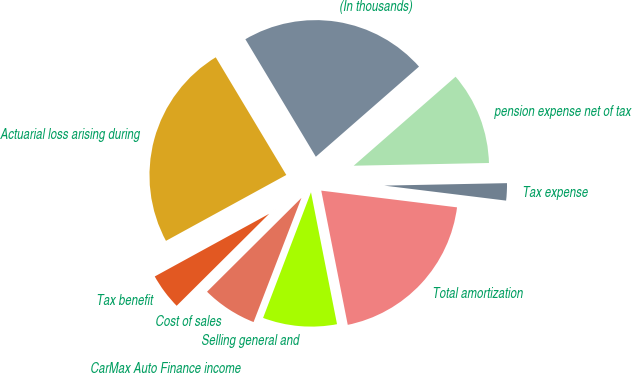Convert chart to OTSL. <chart><loc_0><loc_0><loc_500><loc_500><pie_chart><fcel>(In thousands)<fcel>Actuarial loss arising during<fcel>Tax benefit<fcel>Cost of sales<fcel>CarMax Auto Finance income<fcel>Selling general and<fcel>Total amortization<fcel>Tax expense<fcel>pension expense net of tax<nl><fcel>22.17%<fcel>24.38%<fcel>4.48%<fcel>6.69%<fcel>0.06%<fcel>8.9%<fcel>19.95%<fcel>2.27%<fcel>11.11%<nl></chart> 